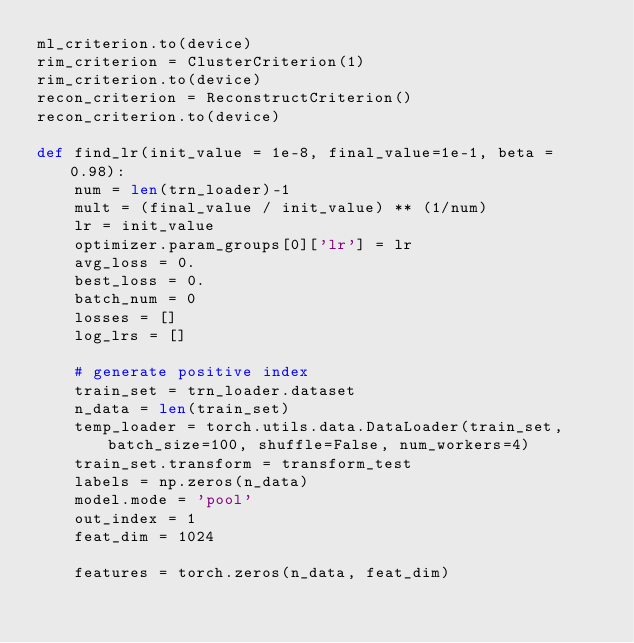Convert code to text. <code><loc_0><loc_0><loc_500><loc_500><_Python_>ml_criterion.to(device)
rim_criterion = ClusterCriterion(1)
rim_criterion.to(device)
recon_criterion = ReconstructCriterion()
recon_criterion.to(device)

def find_lr(init_value = 1e-8, final_value=1e-1, beta = 0.98):
    num = len(trn_loader)-1
    mult = (final_value / init_value) ** (1/num)
    lr = init_value
    optimizer.param_groups[0]['lr'] = lr
    avg_loss = 0.
    best_loss = 0.
    batch_num = 0
    losses = []
    log_lrs = []

    # generate positive index
    train_set = trn_loader.dataset
    n_data = len(train_set)
    temp_loader = torch.utils.data.DataLoader(train_set, batch_size=100, shuffle=False, num_workers=4)
    train_set.transform = transform_test
    labels = np.zeros(n_data)
    model.mode = 'pool'
    out_index = 1
    feat_dim = 1024

    features = torch.zeros(n_data, feat_dim)</code> 